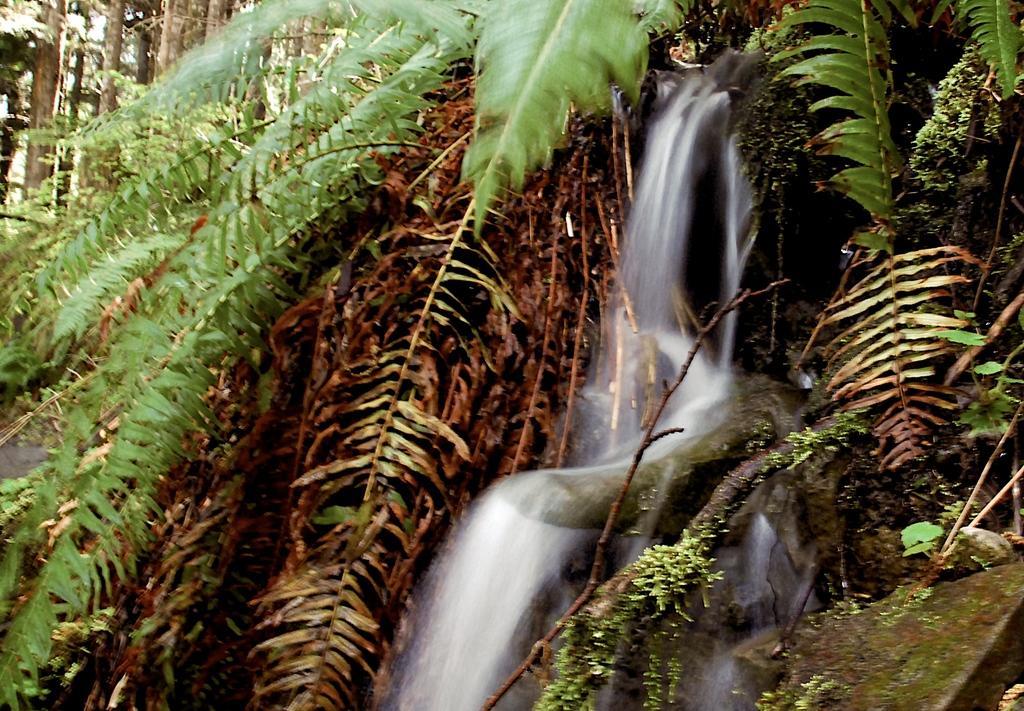Could you give a brief overview of what you see in this image? In this picture we can see the trees, leaves, water, rocks are present. 